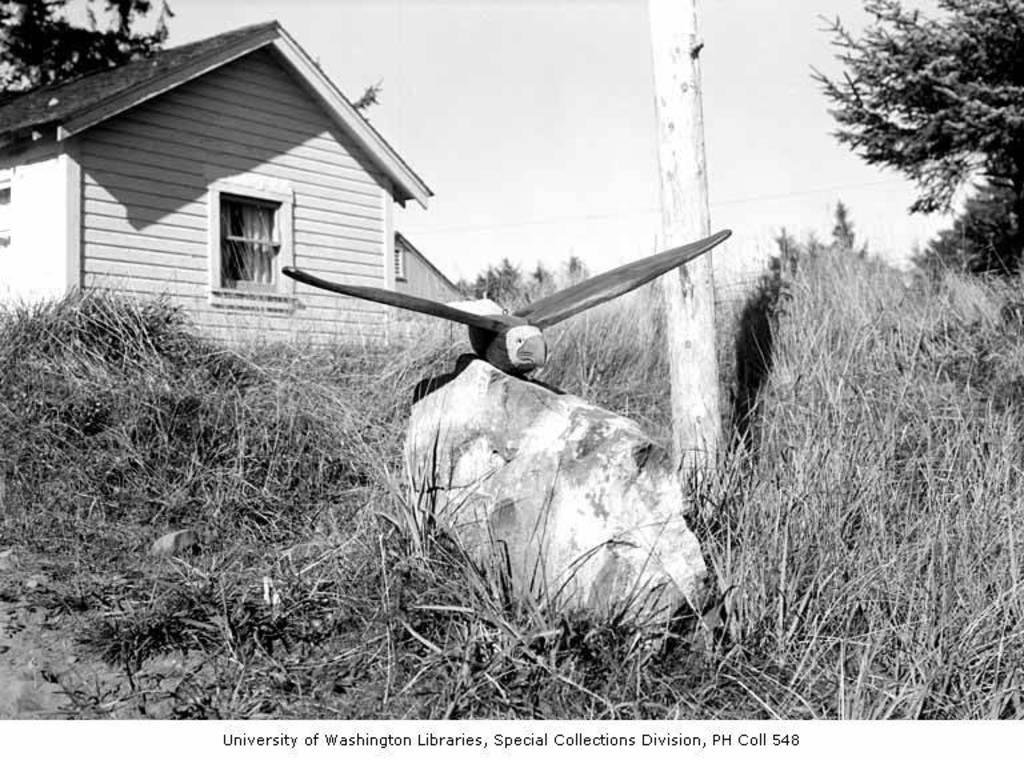Provide a one-sentence caption for the provided image. The Special Collections Division made a beautiful model of an eagle. 